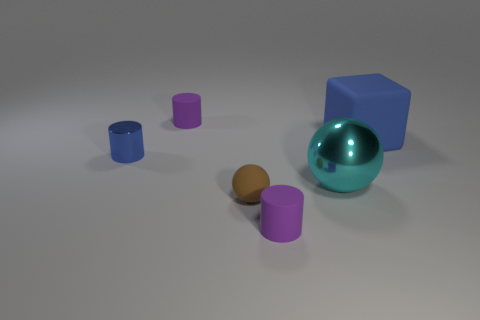What size is the purple thing that is in front of the big cube?
Ensure brevity in your answer.  Small. There is a brown thing; is its size the same as the metallic thing that is behind the big sphere?
Offer a terse response. Yes. There is a small matte cylinder to the left of the purple cylinder in front of the blue metallic cylinder; what color is it?
Your answer should be compact. Purple. How many other things are there of the same color as the metal ball?
Give a very brief answer. 0. The rubber ball is what size?
Offer a very short reply. Small. Is the number of large spheres left of the metallic cylinder greater than the number of small shiny cylinders behind the brown sphere?
Provide a succinct answer. No. There is a purple matte thing that is behind the tiny blue metal object; how many rubber cylinders are to the right of it?
Provide a short and direct response. 1. Is the shape of the tiny purple rubber thing in front of the large matte thing the same as  the small shiny object?
Your answer should be very brief. Yes. There is a big object that is the same shape as the tiny brown thing; what is it made of?
Offer a terse response. Metal. What number of cubes have the same size as the cyan object?
Provide a succinct answer. 1. 